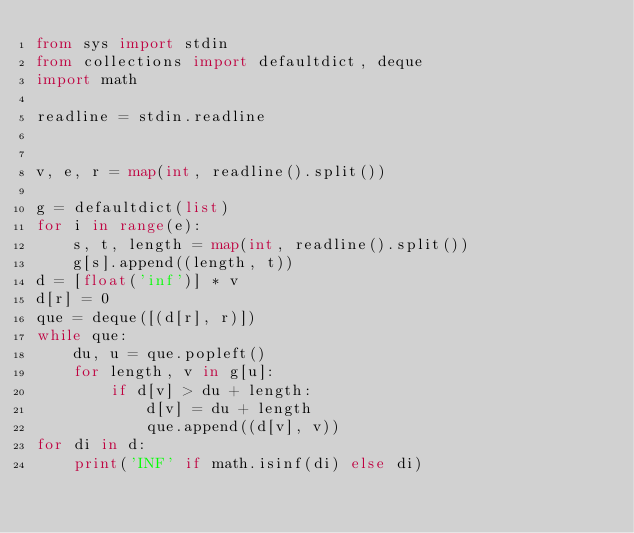Convert code to text. <code><loc_0><loc_0><loc_500><loc_500><_Python_>from sys import stdin
from collections import defaultdict, deque
import math

readline = stdin.readline


v, e, r = map(int, readline().split())

g = defaultdict(list)
for i in range(e):
    s, t, length = map(int, readline().split())
    g[s].append((length, t))
d = [float('inf')] * v
d[r] = 0
que = deque([(d[r], r)])
while que:
    du, u = que.popleft()
    for length, v in g[u]:
        if d[v] > du + length:
            d[v] = du + length
            que.append((d[v], v))
for di in d:
    print('INF' if math.isinf(di) else di)</code> 